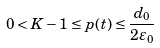Convert formula to latex. <formula><loc_0><loc_0><loc_500><loc_500>0 < K - 1 \leq p ( t ) \leq \frac { d _ { 0 } } { 2 \varepsilon _ { 0 } }</formula> 